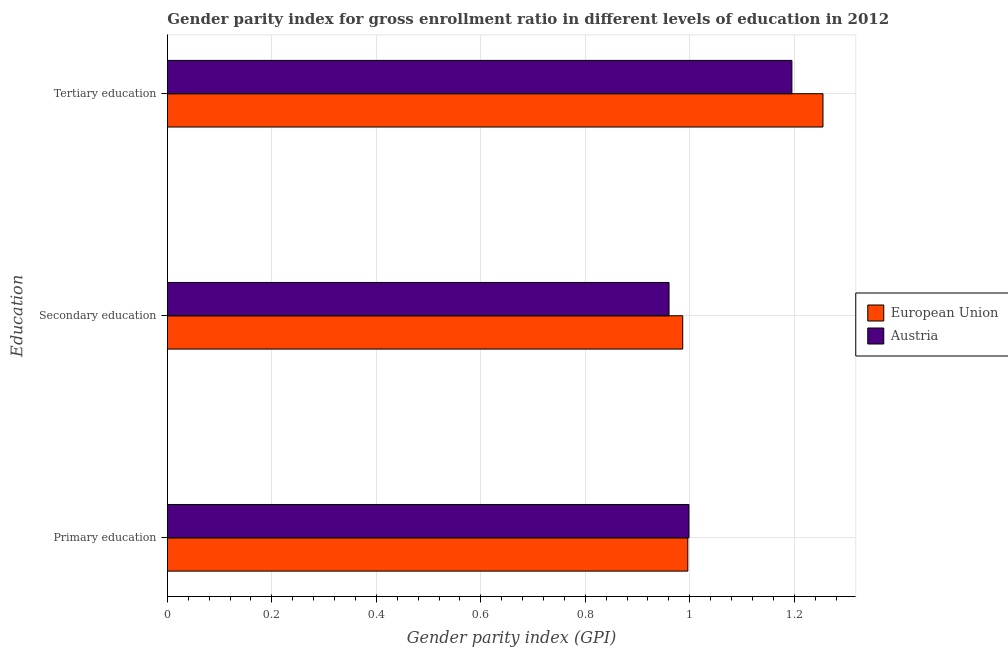Are the number of bars on each tick of the Y-axis equal?
Offer a terse response. Yes. What is the label of the 2nd group of bars from the top?
Give a very brief answer. Secondary education. What is the gender parity index in primary education in European Union?
Your response must be concise. 1. Across all countries, what is the maximum gender parity index in secondary education?
Give a very brief answer. 0.99. Across all countries, what is the minimum gender parity index in tertiary education?
Your answer should be very brief. 1.2. In which country was the gender parity index in primary education minimum?
Offer a very short reply. European Union. What is the total gender parity index in tertiary education in the graph?
Give a very brief answer. 2.45. What is the difference between the gender parity index in tertiary education in European Union and that in Austria?
Provide a succinct answer. 0.06. What is the difference between the gender parity index in primary education in Austria and the gender parity index in tertiary education in European Union?
Offer a terse response. -0.26. What is the average gender parity index in tertiary education per country?
Provide a succinct answer. 1.23. What is the difference between the gender parity index in primary education and gender parity index in tertiary education in European Union?
Ensure brevity in your answer.  -0.26. In how many countries, is the gender parity index in tertiary education greater than 1.16 ?
Your answer should be very brief. 2. What is the ratio of the gender parity index in secondary education in European Union to that in Austria?
Provide a succinct answer. 1.03. What is the difference between the highest and the second highest gender parity index in secondary education?
Your answer should be compact. 0.03. What is the difference between the highest and the lowest gender parity index in primary education?
Your answer should be compact. 0. What does the 2nd bar from the bottom in Tertiary education represents?
Make the answer very short. Austria. Are all the bars in the graph horizontal?
Keep it short and to the point. Yes. How many countries are there in the graph?
Offer a very short reply. 2. What is the difference between two consecutive major ticks on the X-axis?
Make the answer very short. 0.2. How many legend labels are there?
Your answer should be very brief. 2. What is the title of the graph?
Ensure brevity in your answer.  Gender parity index for gross enrollment ratio in different levels of education in 2012. What is the label or title of the X-axis?
Offer a very short reply. Gender parity index (GPI). What is the label or title of the Y-axis?
Give a very brief answer. Education. What is the Gender parity index (GPI) of European Union in Primary education?
Your response must be concise. 1. What is the Gender parity index (GPI) of Austria in Primary education?
Keep it short and to the point. 1. What is the Gender parity index (GPI) of European Union in Secondary education?
Keep it short and to the point. 0.99. What is the Gender parity index (GPI) of Austria in Secondary education?
Your answer should be compact. 0.96. What is the Gender parity index (GPI) of European Union in Tertiary education?
Offer a very short reply. 1.26. What is the Gender parity index (GPI) in Austria in Tertiary education?
Offer a very short reply. 1.2. Across all Education, what is the maximum Gender parity index (GPI) of European Union?
Keep it short and to the point. 1.26. Across all Education, what is the maximum Gender parity index (GPI) in Austria?
Offer a very short reply. 1.2. Across all Education, what is the minimum Gender parity index (GPI) in European Union?
Give a very brief answer. 0.99. Across all Education, what is the minimum Gender parity index (GPI) in Austria?
Your answer should be very brief. 0.96. What is the total Gender parity index (GPI) of European Union in the graph?
Your answer should be compact. 3.24. What is the total Gender parity index (GPI) in Austria in the graph?
Provide a succinct answer. 3.15. What is the difference between the Gender parity index (GPI) of European Union in Primary education and that in Secondary education?
Give a very brief answer. 0.01. What is the difference between the Gender parity index (GPI) in Austria in Primary education and that in Secondary education?
Keep it short and to the point. 0.04. What is the difference between the Gender parity index (GPI) of European Union in Primary education and that in Tertiary education?
Your answer should be very brief. -0.26. What is the difference between the Gender parity index (GPI) of Austria in Primary education and that in Tertiary education?
Keep it short and to the point. -0.2. What is the difference between the Gender parity index (GPI) in European Union in Secondary education and that in Tertiary education?
Make the answer very short. -0.27. What is the difference between the Gender parity index (GPI) in Austria in Secondary education and that in Tertiary education?
Keep it short and to the point. -0.24. What is the difference between the Gender parity index (GPI) in European Union in Primary education and the Gender parity index (GPI) in Austria in Secondary education?
Provide a succinct answer. 0.04. What is the difference between the Gender parity index (GPI) of European Union in Primary education and the Gender parity index (GPI) of Austria in Tertiary education?
Make the answer very short. -0.2. What is the difference between the Gender parity index (GPI) of European Union in Secondary education and the Gender parity index (GPI) of Austria in Tertiary education?
Give a very brief answer. -0.21. What is the average Gender parity index (GPI) of European Union per Education?
Make the answer very short. 1.08. What is the average Gender parity index (GPI) of Austria per Education?
Keep it short and to the point. 1.05. What is the difference between the Gender parity index (GPI) of European Union and Gender parity index (GPI) of Austria in Primary education?
Provide a succinct answer. -0. What is the difference between the Gender parity index (GPI) of European Union and Gender parity index (GPI) of Austria in Secondary education?
Keep it short and to the point. 0.03. What is the difference between the Gender parity index (GPI) in European Union and Gender parity index (GPI) in Austria in Tertiary education?
Provide a succinct answer. 0.06. What is the ratio of the Gender parity index (GPI) of European Union in Primary education to that in Secondary education?
Give a very brief answer. 1.01. What is the ratio of the Gender parity index (GPI) in Austria in Primary education to that in Secondary education?
Your response must be concise. 1.04. What is the ratio of the Gender parity index (GPI) in European Union in Primary education to that in Tertiary education?
Your answer should be very brief. 0.79. What is the ratio of the Gender parity index (GPI) in Austria in Primary education to that in Tertiary education?
Offer a very short reply. 0.84. What is the ratio of the Gender parity index (GPI) of European Union in Secondary education to that in Tertiary education?
Keep it short and to the point. 0.79. What is the ratio of the Gender parity index (GPI) of Austria in Secondary education to that in Tertiary education?
Keep it short and to the point. 0.8. What is the difference between the highest and the second highest Gender parity index (GPI) in European Union?
Your response must be concise. 0.26. What is the difference between the highest and the second highest Gender parity index (GPI) of Austria?
Keep it short and to the point. 0.2. What is the difference between the highest and the lowest Gender parity index (GPI) in European Union?
Keep it short and to the point. 0.27. What is the difference between the highest and the lowest Gender parity index (GPI) of Austria?
Give a very brief answer. 0.24. 